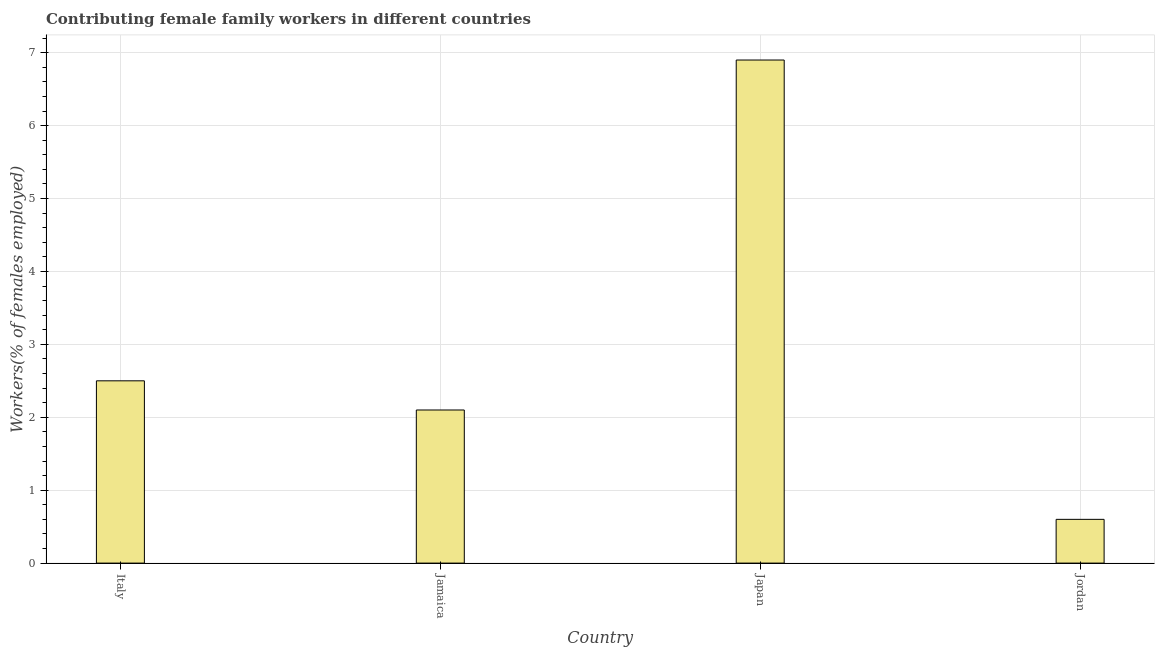Does the graph contain any zero values?
Provide a short and direct response. No. What is the title of the graph?
Provide a short and direct response. Contributing female family workers in different countries. What is the label or title of the X-axis?
Your answer should be very brief. Country. What is the label or title of the Y-axis?
Provide a short and direct response. Workers(% of females employed). What is the contributing female family workers in Jordan?
Make the answer very short. 0.6. Across all countries, what is the maximum contributing female family workers?
Provide a succinct answer. 6.9. Across all countries, what is the minimum contributing female family workers?
Provide a succinct answer. 0.6. In which country was the contributing female family workers minimum?
Provide a succinct answer. Jordan. What is the sum of the contributing female family workers?
Give a very brief answer. 12.1. What is the average contributing female family workers per country?
Your answer should be very brief. 3.02. What is the median contributing female family workers?
Ensure brevity in your answer.  2.3. In how many countries, is the contributing female family workers greater than 6.4 %?
Offer a terse response. 1. What is the ratio of the contributing female family workers in Italy to that in Jamaica?
Provide a succinct answer. 1.19. Is the difference between the contributing female family workers in Jamaica and Japan greater than the difference between any two countries?
Offer a terse response. No. Are all the bars in the graph horizontal?
Make the answer very short. No. What is the Workers(% of females employed) of Italy?
Give a very brief answer. 2.5. What is the Workers(% of females employed) in Jamaica?
Ensure brevity in your answer.  2.1. What is the Workers(% of females employed) of Japan?
Give a very brief answer. 6.9. What is the Workers(% of females employed) in Jordan?
Offer a very short reply. 0.6. What is the difference between the Workers(% of females employed) in Italy and Jordan?
Your answer should be compact. 1.9. What is the difference between the Workers(% of females employed) in Jamaica and Japan?
Keep it short and to the point. -4.8. What is the difference between the Workers(% of females employed) in Japan and Jordan?
Your answer should be compact. 6.3. What is the ratio of the Workers(% of females employed) in Italy to that in Jamaica?
Give a very brief answer. 1.19. What is the ratio of the Workers(% of females employed) in Italy to that in Japan?
Offer a terse response. 0.36. What is the ratio of the Workers(% of females employed) in Italy to that in Jordan?
Offer a very short reply. 4.17. What is the ratio of the Workers(% of females employed) in Jamaica to that in Japan?
Offer a very short reply. 0.3. What is the ratio of the Workers(% of females employed) in Jamaica to that in Jordan?
Your answer should be very brief. 3.5. What is the ratio of the Workers(% of females employed) in Japan to that in Jordan?
Your answer should be very brief. 11.5. 